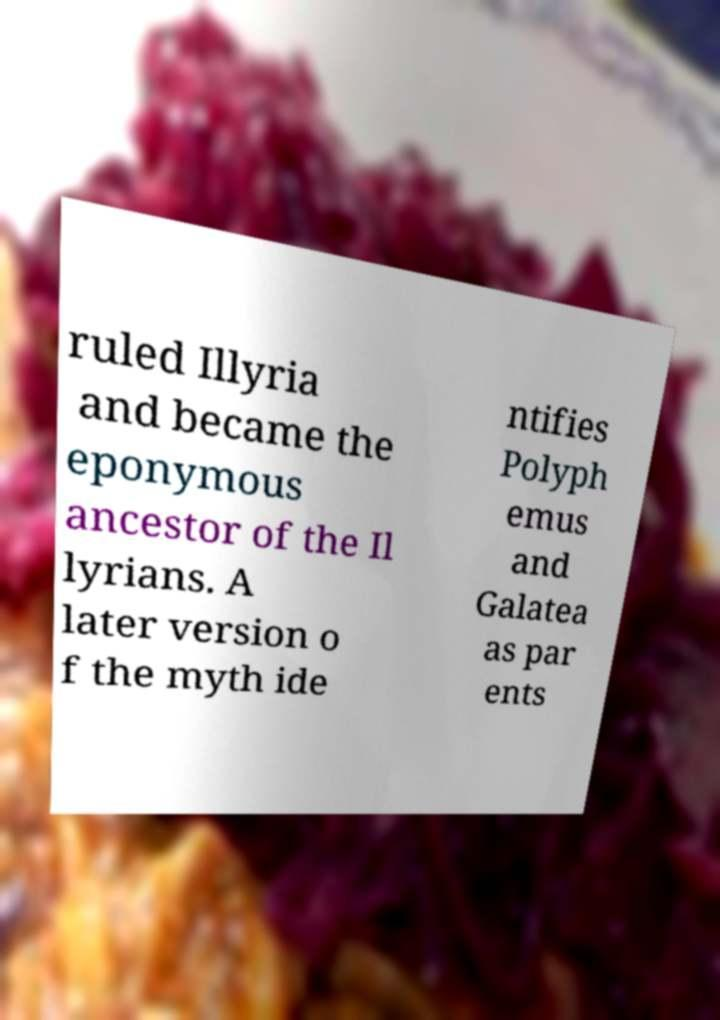I need the written content from this picture converted into text. Can you do that? ruled Illyria and became the eponymous ancestor of the Il lyrians. A later version o f the myth ide ntifies Polyph emus and Galatea as par ents 